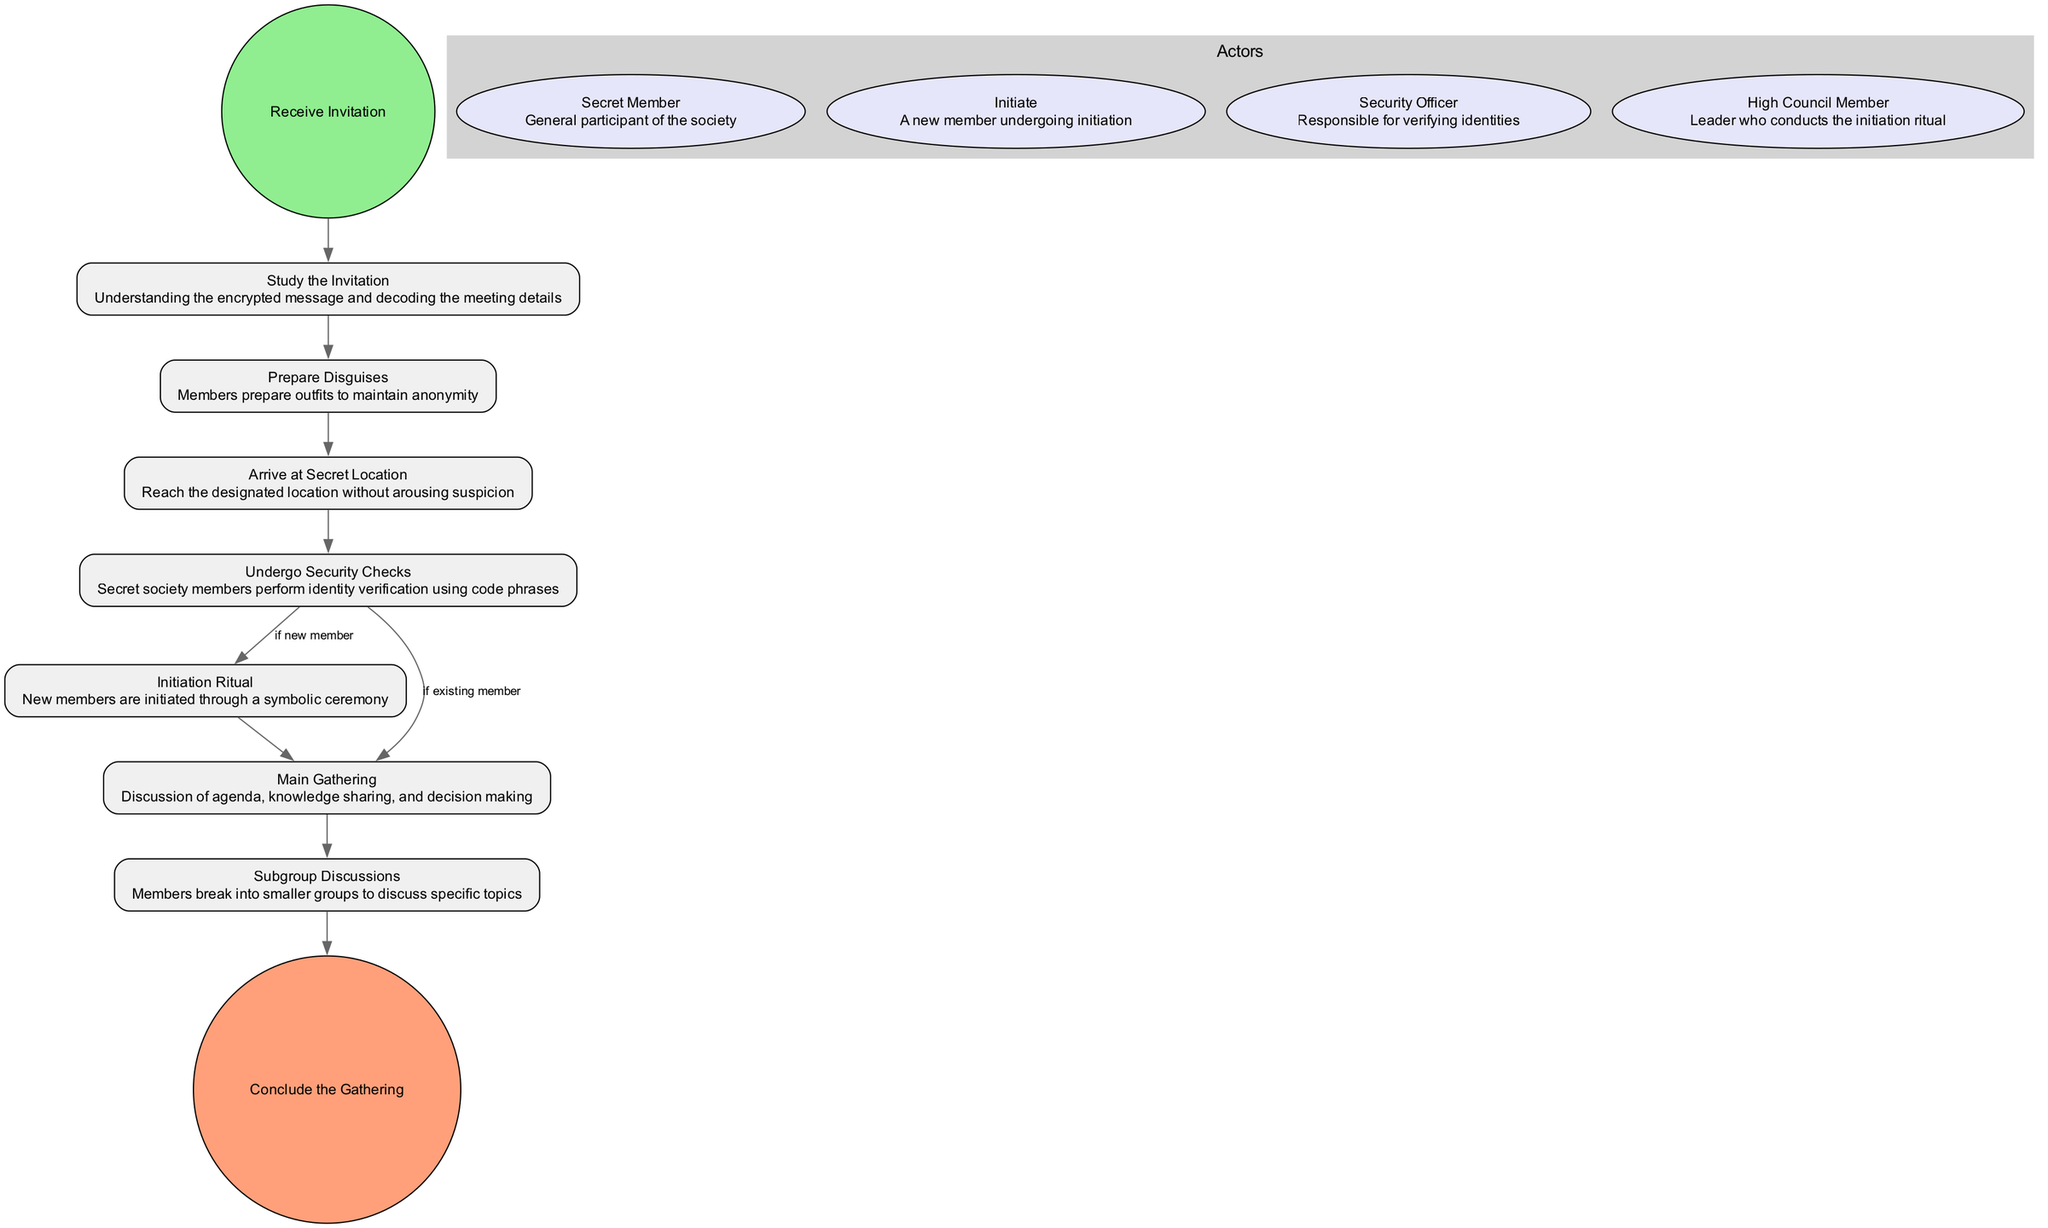What is the starting activity in the diagram? The starting activity is "Receive Invitation," which is represented as the first node and marked as the starting point of the process in the diagram.
Answer: Receive Invitation How many activities are shown in the diagram? By counting the activities listed in the data, there are a total of 9 activities depicted within the diagram.
Answer: 9 What happens after "Undergo Security Checks" if the member is new? After "Undergo Security Checks," if the member is new, the flow transitions to the next activity labeled "Initiation Ritual."
Answer: Initiation Ritual Which role is responsible for verifying identities? The "Security Officer" is the role designated to conduct identity verification as indicated in the actors' section of the diagram.
Answer: Security Officer What is the final activity to conclude the process? The final activity that concludes the gathering is labeled "Conclude the Gathering," indicating the end of the sequence.
Answer: Conclude the Gathering What activity follows "Main Gathering"? The activity that follows "Main Gathering" is "Subgroup Discussions," signifying a shift to smaller group discussions.
Answer: Subgroup Discussions What condition leads to "Main Gathering" from "Undergo Security Checks"? The condition that leads to "Main Gathering" from "Undergo Security Checks" is if the individual is an existing member, as specified in the transitions section.
Answer: if existing member How many actors are involved in the diagram? The diagram includes 4 distinct actors, each with a designated role within the secret society.
Answer: 4 What is the relationship between "Initiation Ritual" and "Main Gathering"? The relationship is that "Initiation Ritual" directly leads to "Main Gathering," indicating a sequential flow from initiation to the main discussions.
Answer: Main Gathering 